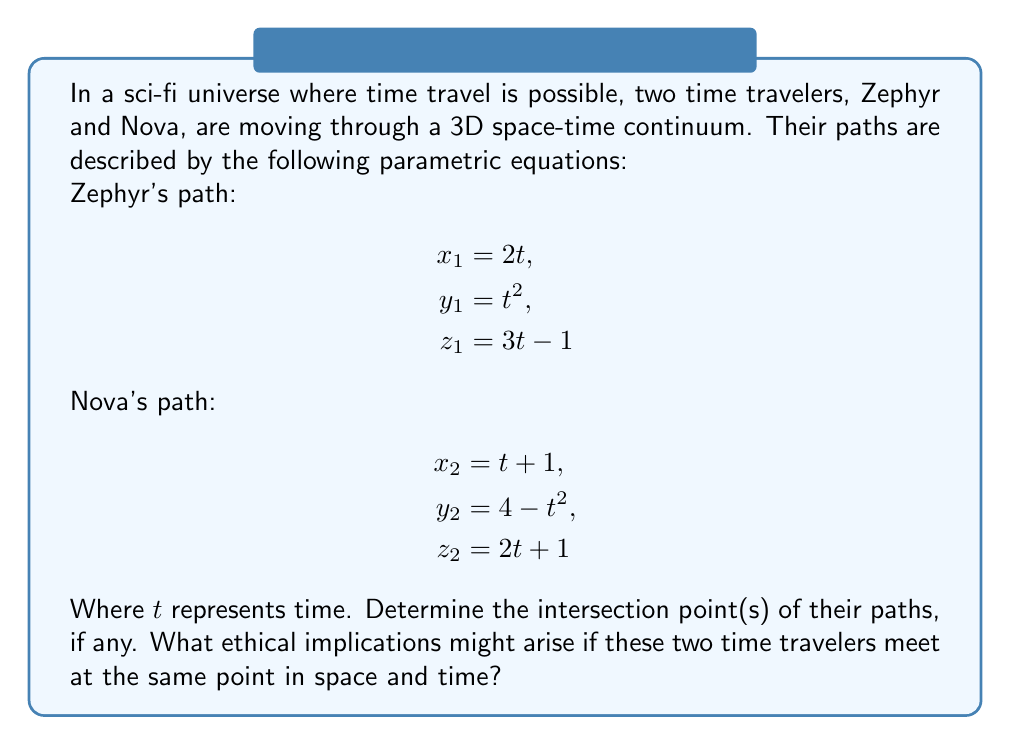Could you help me with this problem? To find the intersection point(s) of the two time travelers' paths, we need to solve the system of equations where their coordinates are equal:

$$\begin{cases}
2t_1 = t_2 + 1 \\
t_1^2 = 4 - t_2^2 \\
3t_1 - 1 = 2t_2 + 1
\end{cases}$$

Where $t_1$ is Zephyr's time parameter and $t_2$ is Nova's time parameter.

Step 1: From the first equation, express $t_2$ in terms of $t_1$:
$$t_2 = 2t_1 - 1$$

Step 2: Substitute this into the third equation:
$$3t_1 - 1 = 2(2t_1 - 1) + 1$$
$$3t_1 - 1 = 4t_1 - 1$$
$$-t_1 = 0$$
$$t_1 = 0$$

Step 3: Substitute $t_1 = 0$ into the equation from Step 1:
$$t_2 = 2(0) - 1 = -1$$

Step 4: Verify these values satisfy the second equation:
$$(0)^2 = 4 - (-1)^2$$
$$0 = 4 - 1$$
$$0 = 3$$ (This is not true)

Since the values don't satisfy all equations simultaneously, there is no intersection point between the two paths.

Ethical implications:
1. Avoiding paradoxes: The fact that the time travelers don't meet might prevent potential time paradoxes.
2. Non-interference: This scenario ensures that the two time travelers don't interfere with each other's missions or timelines.
3. Preservation of causality: The lack of intersection helps maintain the integrity of cause-and-effect relationships in the timeline.
Answer: The time travelers' paths do not intersect. There is no solution to the system of equations, indicating that Zephyr and Nova never meet at the same point in space and time. 